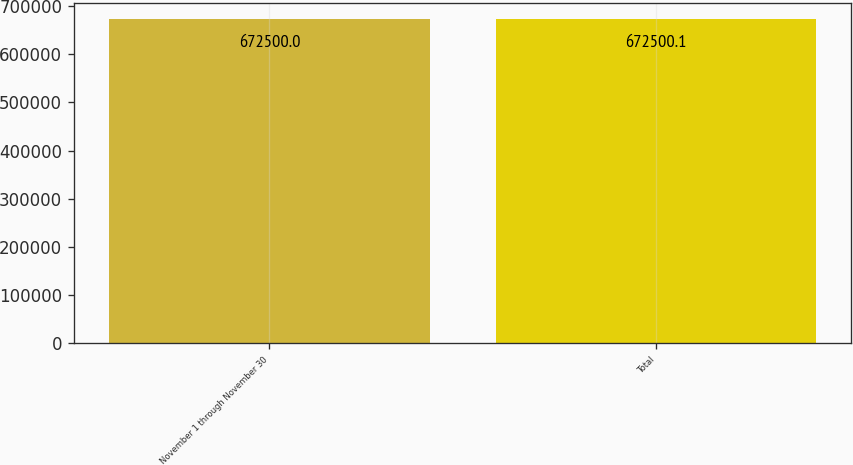Convert chart. <chart><loc_0><loc_0><loc_500><loc_500><bar_chart><fcel>November 1 through November 30<fcel>Total<nl><fcel>672500<fcel>672500<nl></chart> 